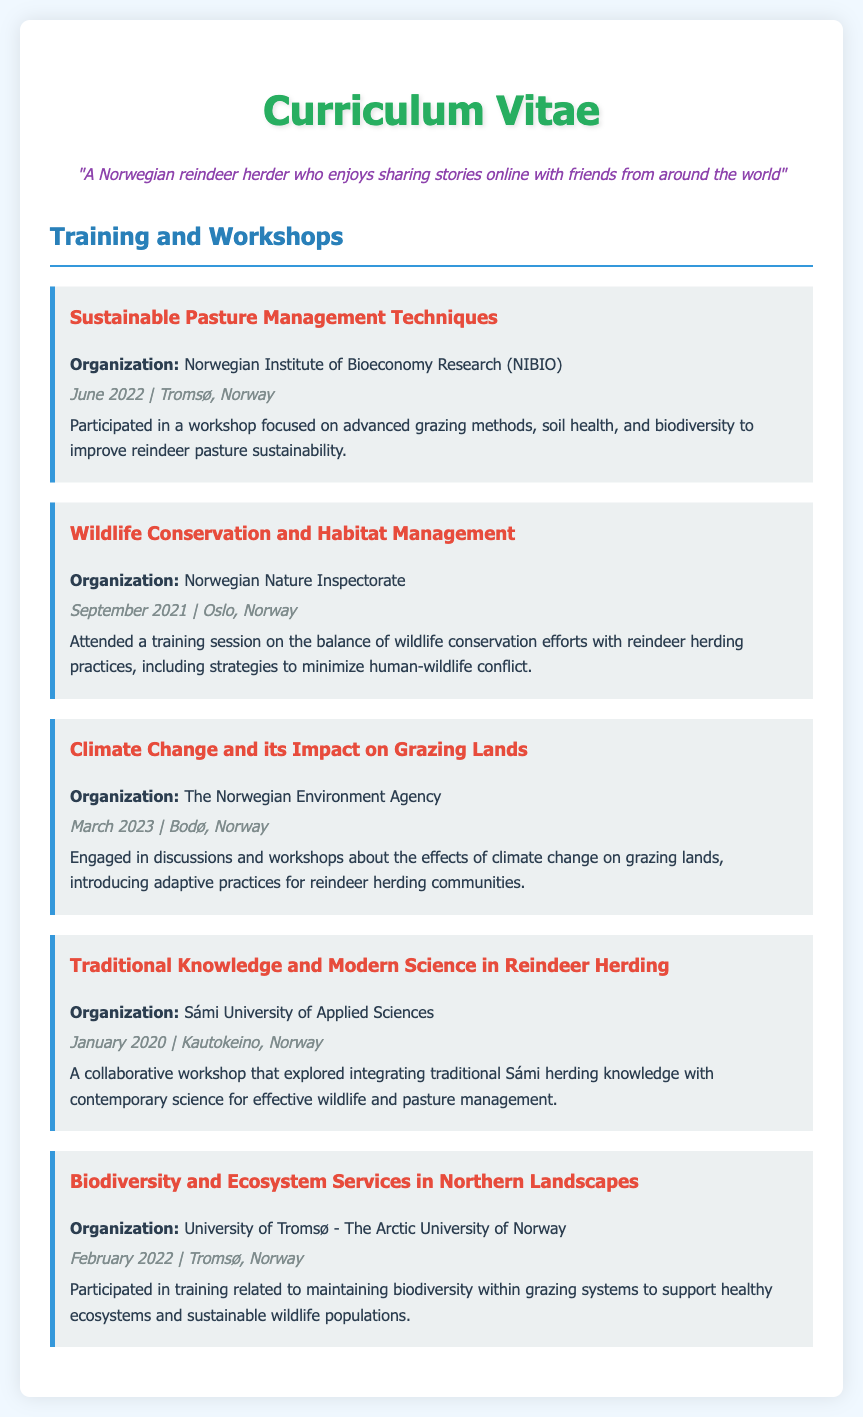What is the title of the first workshop? The title of the first workshop listed in the document is "Sustainable Pasture Management Techniques."
Answer: Sustainable Pasture Management Techniques Who organized the workshop on wildlife conservation? The workshop on wildlife conservation was organized by the Norwegian Nature Inspectorate.
Answer: Norwegian Nature Inspectorate In which month and year did the workshop on climate change take place? The workshop on climate change took place in March 2023.
Answer: March 2023 What is the focus of the workshop conducted by Sámi University of Applied Sciences? The focus of the workshop is on integrating traditional Sámi herding knowledge with contemporary science for effective wildlife and pasture management.
Answer: Integrating traditional Sámi herding knowledge How many workshops are listed in total? The document lists a total of five workshops attended by the Norwegian reindeer herder.
Answer: Five What is the date of the workshop focused on biodiversity? The date of the biodiversity workshop is February 2022.
Answer: February 2022 Which organization conducted the workshop on sustainable grazing practices? The organization that conducted the workshop on sustainable grazing practices is the Norwegian Institute of Bioeconomy Research (NIBIO).
Answer: Norwegian Institute of Bioeconomy Research (NIBIO) What city hosted the workshop on climate change? The workshop on climate change was hosted in Bodø, Norway.
Answer: Bodø, Norway Which training session emphasizes minimizing human-wildlife conflict? The training session that emphasizes minimizing human-wildlife conflict is "Wildlife Conservation and Habitat Management."
Answer: Wildlife Conservation and Habitat Management 